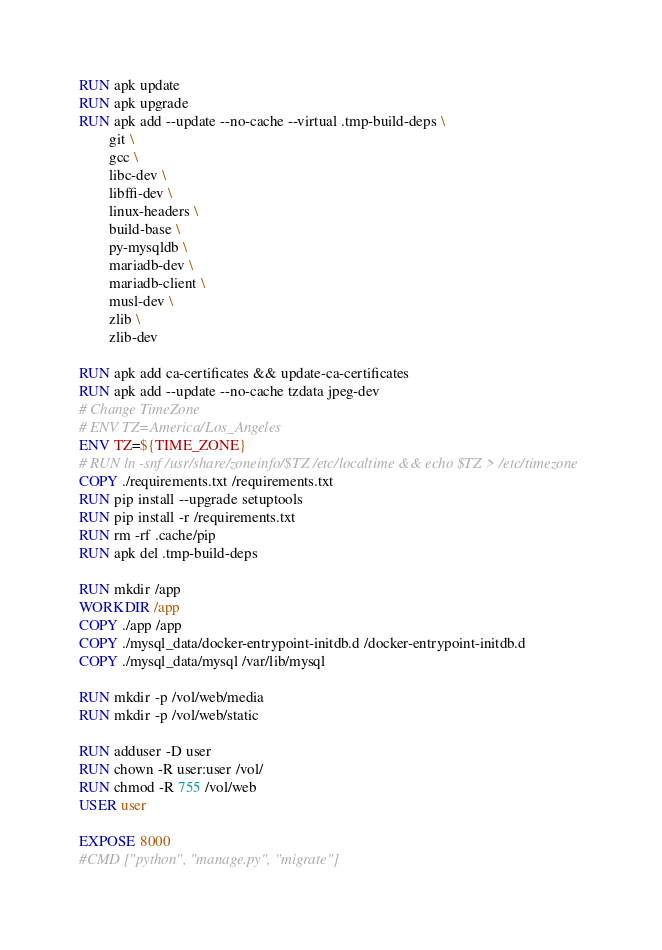<code> <loc_0><loc_0><loc_500><loc_500><_Dockerfile_>
RUN apk update
RUN apk upgrade
RUN apk add --update --no-cache --virtual .tmp-build-deps \
        git \
        gcc \
        libc-dev \
        libffi-dev \
        linux-headers \
        build-base \
        py-mysqldb \
        mariadb-dev \
        mariadb-client \
        musl-dev \
        zlib \
        zlib-dev
        
RUN apk add ca-certificates && update-ca-certificates
RUN apk add --update --no-cache tzdata jpeg-dev
# Change TimeZone
# ENV TZ=America/Los_Angeles
ENV TZ=${TIME_ZONE}
# RUN ln -snf /usr/share/zoneinfo/$TZ /etc/localtime && echo $TZ > /etc/timezone
COPY ./requirements.txt /requirements.txt
RUN pip install --upgrade setuptools
RUN pip install -r /requirements.txt
RUN rm -rf .cache/pip
RUN apk del .tmp-build-deps

RUN mkdir /app
WORKDIR /app
COPY ./app /app
COPY ./mysql_data/docker-entrypoint-initdb.d /docker-entrypoint-initdb.d
COPY ./mysql_data/mysql /var/lib/mysql

RUN mkdir -p /vol/web/media
RUN mkdir -p /vol/web/static

RUN adduser -D user
RUN chown -R user:user /vol/
RUN chmod -R 755 /vol/web
USER user

EXPOSE 8000
#CMD ["python", "manage.py", "migrate"]
</code> 